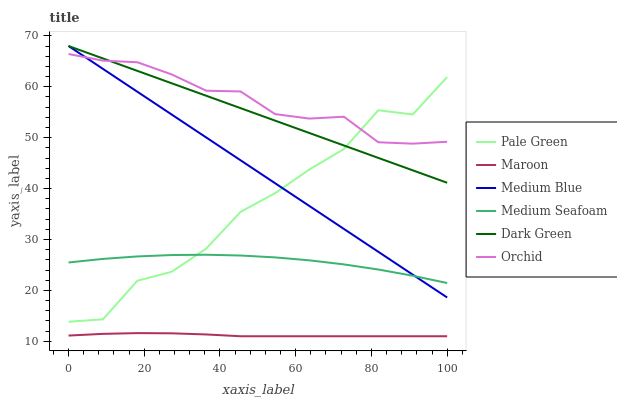Does Maroon have the minimum area under the curve?
Answer yes or no. Yes. Does Orchid have the maximum area under the curve?
Answer yes or no. Yes. Does Pale Green have the minimum area under the curve?
Answer yes or no. No. Does Pale Green have the maximum area under the curve?
Answer yes or no. No. Is Dark Green the smoothest?
Answer yes or no. Yes. Is Pale Green the roughest?
Answer yes or no. Yes. Is Maroon the smoothest?
Answer yes or no. No. Is Maroon the roughest?
Answer yes or no. No. Does Maroon have the lowest value?
Answer yes or no. Yes. Does Pale Green have the lowest value?
Answer yes or no. No. Does Dark Green have the highest value?
Answer yes or no. Yes. Does Pale Green have the highest value?
Answer yes or no. No. Is Maroon less than Dark Green?
Answer yes or no. Yes. Is Orchid greater than Maroon?
Answer yes or no. Yes. Does Medium Blue intersect Pale Green?
Answer yes or no. Yes. Is Medium Blue less than Pale Green?
Answer yes or no. No. Is Medium Blue greater than Pale Green?
Answer yes or no. No. Does Maroon intersect Dark Green?
Answer yes or no. No. 